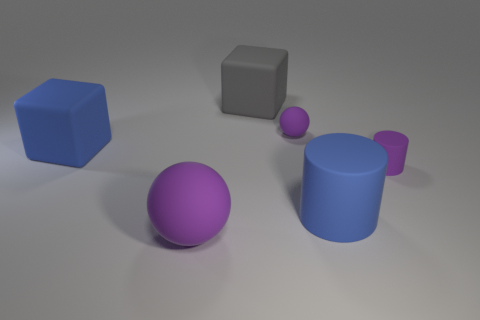Do the big object that is right of the big gray rubber object and the object that is on the right side of the large cylinder have the same shape?
Offer a very short reply. Yes. What number of things are either small purple matte cylinders or blue rubber objects that are on the right side of the large ball?
Provide a succinct answer. 2. How many other things are there of the same shape as the big gray matte thing?
Your response must be concise. 1. Do the purple sphere on the right side of the big gray rubber thing and the tiny cylinder have the same material?
Provide a succinct answer. Yes. What number of objects are big purple shiny objects or balls?
Provide a succinct answer. 2. What size is the other rubber thing that is the same shape as the large purple matte thing?
Keep it short and to the point. Small. What is the size of the purple cylinder?
Keep it short and to the point. Small. Are there more small objects in front of the tiny matte sphere than large gray shiny spheres?
Provide a short and direct response. Yes. Is there any other thing that is the same material as the big purple ball?
Keep it short and to the point. Yes. Is the color of the rubber cylinder in front of the purple matte cylinder the same as the big matte cube left of the big gray thing?
Offer a very short reply. Yes. 